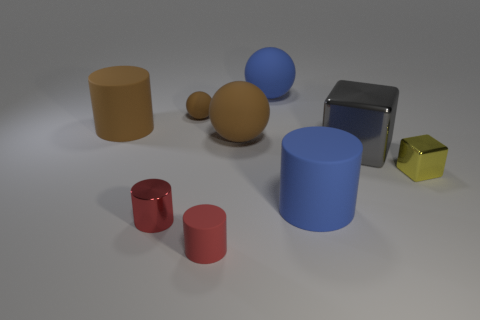Subtract 2 cylinders. How many cylinders are left? 2 Add 2 tiny green metal objects. How many tiny green metal objects exist? 2 Subtract all blue cylinders. How many cylinders are left? 3 Subtract all big balls. How many balls are left? 1 Subtract 0 yellow spheres. How many objects are left? 9 Subtract all cylinders. How many objects are left? 5 Subtract all yellow cubes. Subtract all red spheres. How many cubes are left? 1 Subtract all cyan cubes. How many blue balls are left? 1 Subtract all purple cylinders. Subtract all tiny matte cylinders. How many objects are left? 8 Add 8 metallic cylinders. How many metallic cylinders are left? 9 